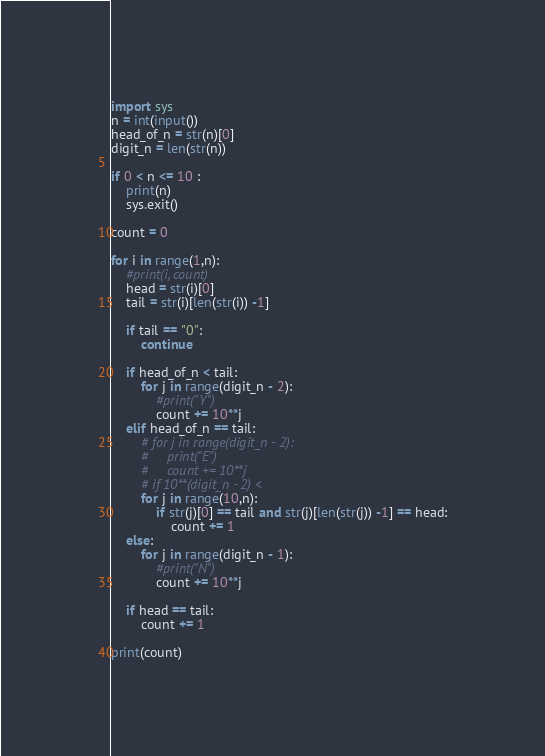Convert code to text. <code><loc_0><loc_0><loc_500><loc_500><_Python_>import sys
n = int(input())
head_of_n = str(n)[0]
digit_n = len(str(n))

if 0 < n <= 10 :
    print(n)
    sys.exit()

count = 0

for i in range(1,n):
    #print(i, count)
    head = str(i)[0]
    tail = str(i)[len(str(i)) -1]

    if tail == "0":
        continue

    if head_of_n < tail:
        for j in range(digit_n - 2):
            #print("Y")
            count += 10**j
    elif head_of_n == tail:
        # for j in range(digit_n - 2):
        #     print("E")
        #     count += 10**j
        # if 10**(digit_n - 2) < 
        for j in range(10,n):
            if str(j)[0] == tail and str(j)[len(str(j)) -1] == head:
                count += 1
    else:
        for j in range(digit_n - 1):
            #print("N")
            count += 10**j

    if head == tail:
        count += 1
        
print(count)</code> 